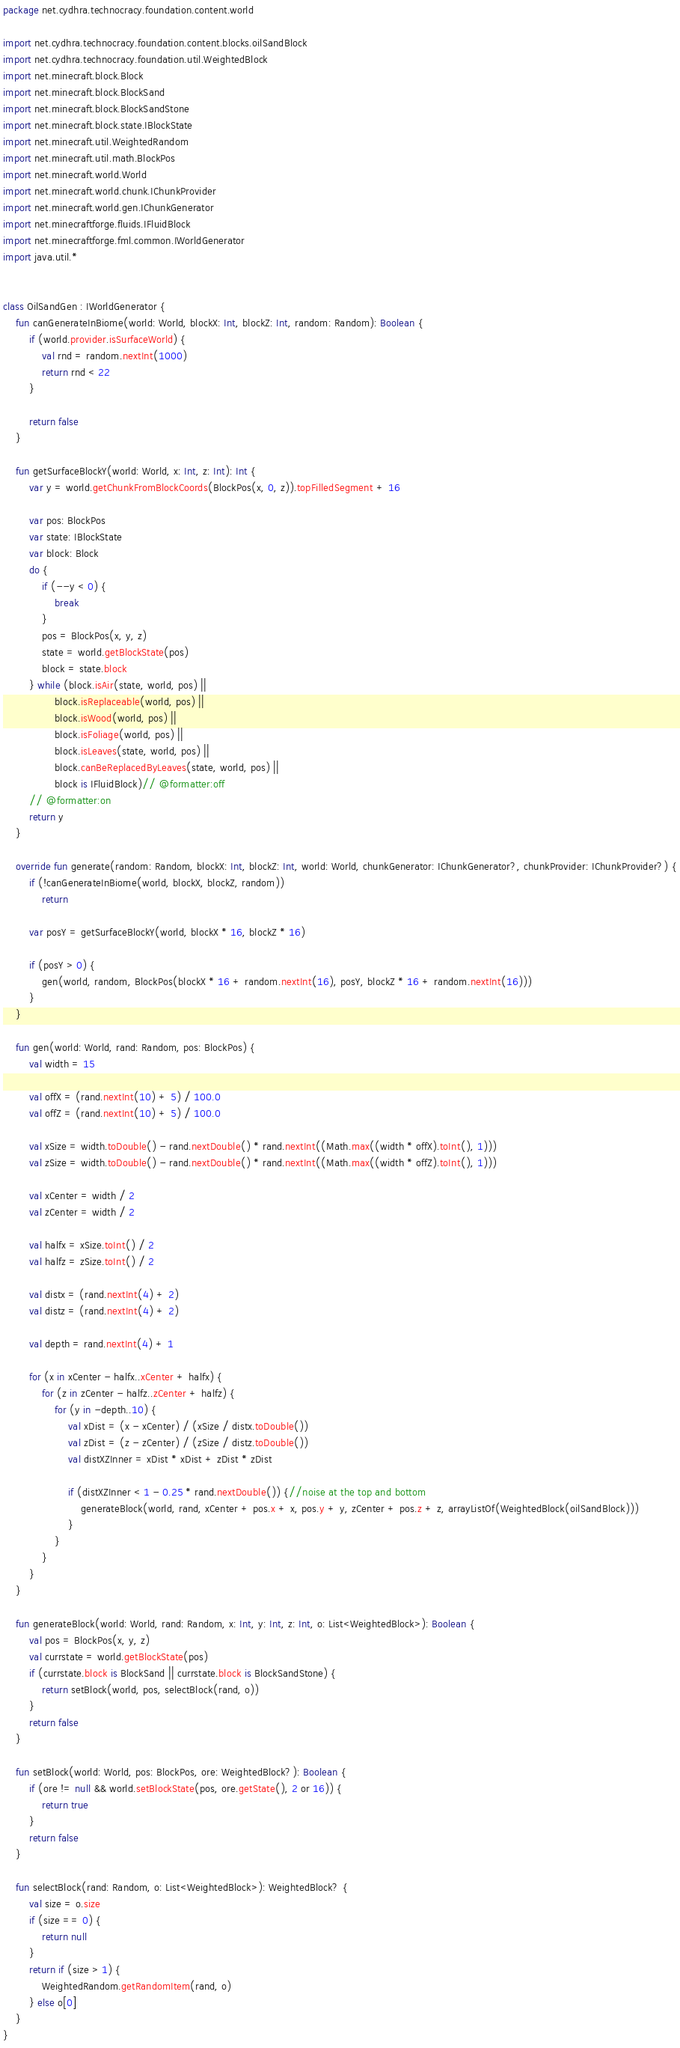Convert code to text. <code><loc_0><loc_0><loc_500><loc_500><_Kotlin_>package net.cydhra.technocracy.foundation.content.world

import net.cydhra.technocracy.foundation.content.blocks.oilSandBlock
import net.cydhra.technocracy.foundation.util.WeightedBlock
import net.minecraft.block.Block
import net.minecraft.block.BlockSand
import net.minecraft.block.BlockSandStone
import net.minecraft.block.state.IBlockState
import net.minecraft.util.WeightedRandom
import net.minecraft.util.math.BlockPos
import net.minecraft.world.World
import net.minecraft.world.chunk.IChunkProvider
import net.minecraft.world.gen.IChunkGenerator
import net.minecraftforge.fluids.IFluidBlock
import net.minecraftforge.fml.common.IWorldGenerator
import java.util.*


class OilSandGen : IWorldGenerator {
    fun canGenerateInBiome(world: World, blockX: Int, blockZ: Int, random: Random): Boolean {
        if (world.provider.isSurfaceWorld) {
            val rnd = random.nextInt(1000)
            return rnd < 22
        }

        return false
    }

    fun getSurfaceBlockY(world: World, x: Int, z: Int): Int {
        var y = world.getChunkFromBlockCoords(BlockPos(x, 0, z)).topFilledSegment + 16

        var pos: BlockPos
        var state: IBlockState
        var block: Block
        do {
            if (--y < 0) {
                break
            }
            pos = BlockPos(x, y, z)
            state = world.getBlockState(pos)
            block = state.block
        } while (block.isAir(state, world, pos) ||
                block.isReplaceable(world, pos) ||
                block.isWood(world, pos) ||
                block.isFoliage(world, pos) ||
                block.isLeaves(state, world, pos) ||
                block.canBeReplacedByLeaves(state, world, pos) ||
                block is IFluidBlock)// @formatter:off
        // @formatter:on
        return y
    }

    override fun generate(random: Random, blockX: Int, blockZ: Int, world: World, chunkGenerator: IChunkGenerator?, chunkProvider: IChunkProvider?) {
        if (!canGenerateInBiome(world, blockX, blockZ, random))
            return

        var posY = getSurfaceBlockY(world, blockX * 16, blockZ * 16)

        if (posY > 0) {
            gen(world, random, BlockPos(blockX * 16 + random.nextInt(16), posY, blockZ * 16 + random.nextInt(16)))
        }
    }

    fun gen(world: World, rand: Random, pos: BlockPos) {
        val width = 15

        val offX = (rand.nextInt(10) + 5) / 100.0
        val offZ = (rand.nextInt(10) + 5) / 100.0

        val xSize = width.toDouble() - rand.nextDouble() * rand.nextInt((Math.max((width * offX).toInt(), 1)))
        val zSize = width.toDouble() - rand.nextDouble() * rand.nextInt((Math.max((width * offZ).toInt(), 1)))

        val xCenter = width / 2
        val zCenter = width / 2

        val halfx = xSize.toInt() / 2
        val halfz = zSize.toInt() / 2

        val distx = (rand.nextInt(4) + 2)
        val distz = (rand.nextInt(4) + 2)

        val depth = rand.nextInt(4) + 1

        for (x in xCenter - halfx..xCenter + halfx) {
            for (z in zCenter - halfz..zCenter + halfz) {
                for (y in -depth..10) {
                    val xDist = (x - xCenter) / (xSize / distx.toDouble())
                    val zDist = (z - zCenter) / (zSize / distz.toDouble())
                    val distXZInner = xDist * xDist + zDist * zDist

                    if (distXZInner < 1 - 0.25 * rand.nextDouble()) {//noise at the top and bottom
                        generateBlock(world, rand, xCenter + pos.x + x, pos.y + y, zCenter + pos.z + z, arrayListOf(WeightedBlock(oilSandBlock)))
                    }
                }
            }
        }
    }

    fun generateBlock(world: World, rand: Random, x: Int, y: Int, z: Int, o: List<WeightedBlock>): Boolean {
        val pos = BlockPos(x, y, z)
        val currstate = world.getBlockState(pos)
        if (currstate.block is BlockSand || currstate.block is BlockSandStone) {
            return setBlock(world, pos, selectBlock(rand, o))
        }
        return false
    }

    fun setBlock(world: World, pos: BlockPos, ore: WeightedBlock?): Boolean {
        if (ore != null && world.setBlockState(pos, ore.getState(), 2 or 16)) {
            return true
        }
        return false
    }

    fun selectBlock(rand: Random, o: List<WeightedBlock>): WeightedBlock? {
        val size = o.size
        if (size == 0) {
            return null
        }
        return if (size > 1) {
            WeightedRandom.getRandomItem(rand, o)
        } else o[0]
    }
}</code> 